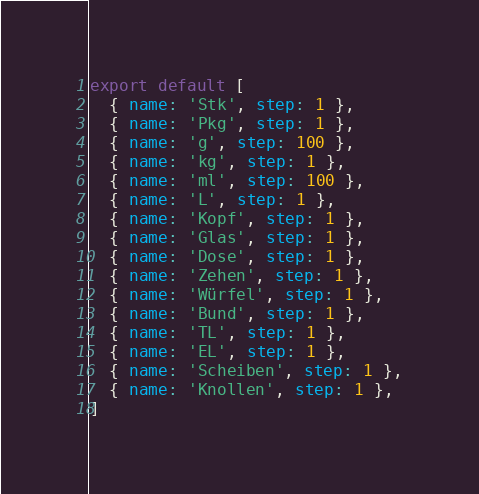Convert code to text. <code><loc_0><loc_0><loc_500><loc_500><_TypeScript_>export default [
  { name: 'Stk', step: 1 },
  { name: 'Pkg', step: 1 },
  { name: 'g', step: 100 },
  { name: 'kg', step: 1 },
  { name: 'ml', step: 100 },
  { name: 'L', step: 1 },
  { name: 'Kopf', step: 1 },
  { name: 'Glas', step: 1 },
  { name: 'Dose', step: 1 },
  { name: 'Zehen', step: 1 },
  { name: 'Würfel', step: 1 },
  { name: 'Bund', step: 1 },
  { name: 'TL', step: 1 },
  { name: 'EL', step: 1 },
  { name: 'Scheiben', step: 1 },
  { name: 'Knollen', step: 1 },
]
</code> 